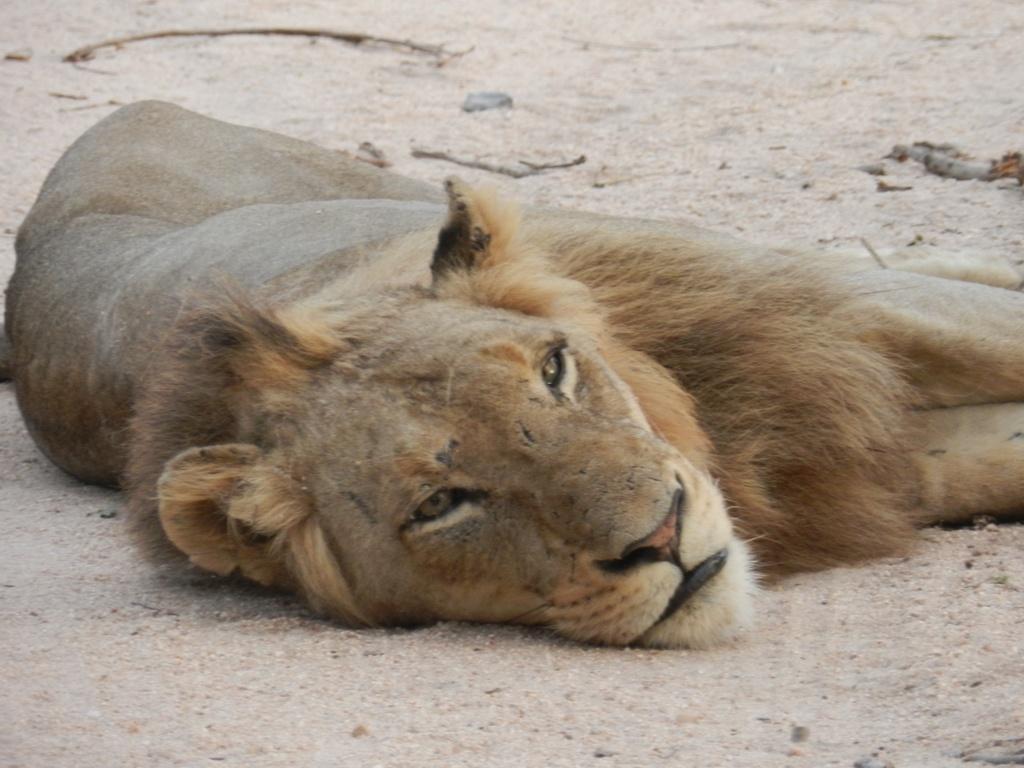Describe this image in one or two sentences. In this image I can see a lion is lying on the ground. This image is taken during a day. 